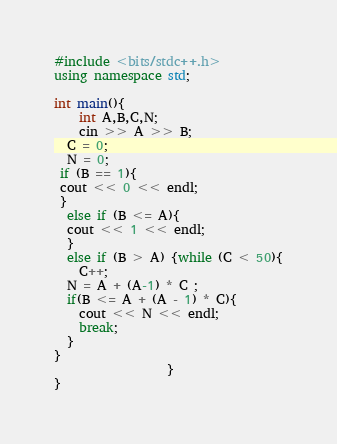<code> <loc_0><loc_0><loc_500><loc_500><_C++_>#include <bits/stdc++.h>
using namespace std;

int main(){
    int A,B,C,N;
    cin >> A >> B;
  C = 0;
  N = 0;
 if (B == 1){
 cout << 0 << endl;
 }
  else if (B <= A){
  cout << 1 << endl;
  }
  else if (B > A) {while (C < 50){
    C++;
  N = A + (A-1) * C ;
  if(B <= A + (A - 1) * C){
    cout << N << endl;
    break;
  }
}
                  }  
}
</code> 